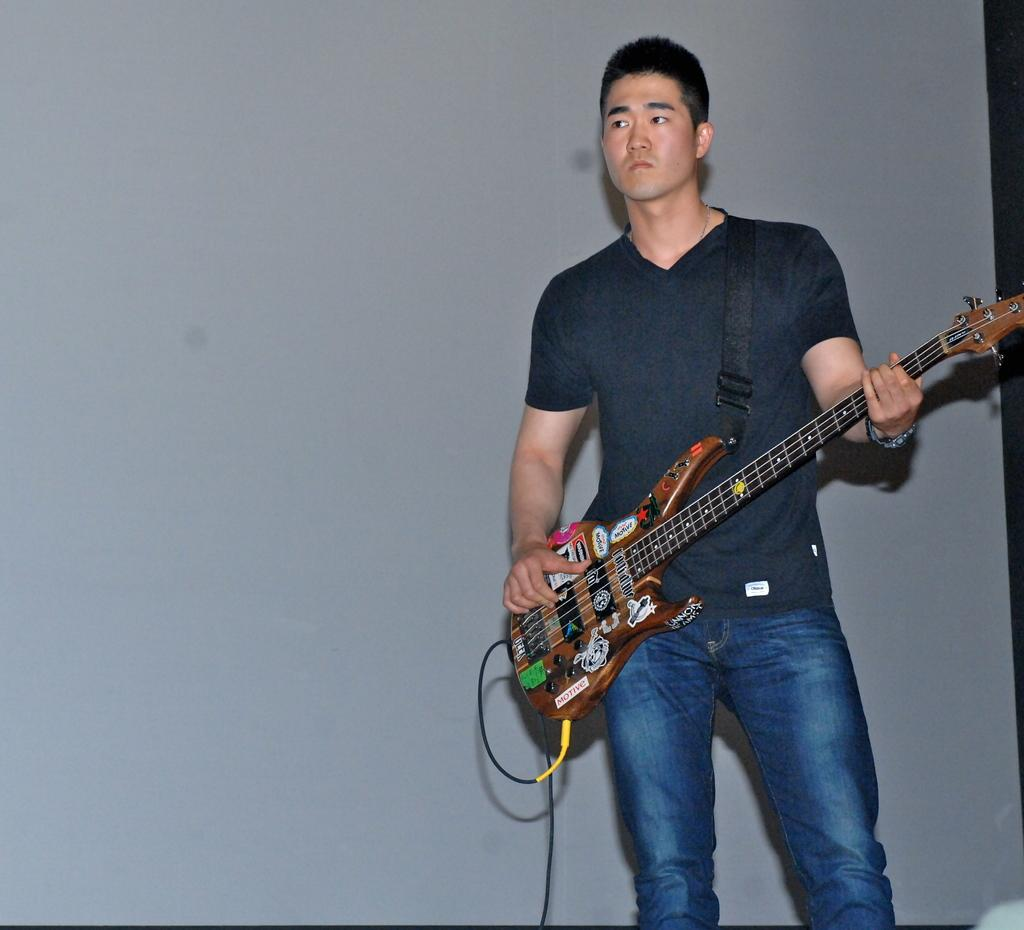Who is the main subject in the image? There is a person in the image. What is the person holding in the image? The person is holding a guitar. What is the person doing with the guitar? The person is playing the guitar. What can be seen in the background of the image? There is a wall in the background of the image. What type of bell can be heard ringing in the image? There is no bell present in the image, and therefore no sound can be heard. 